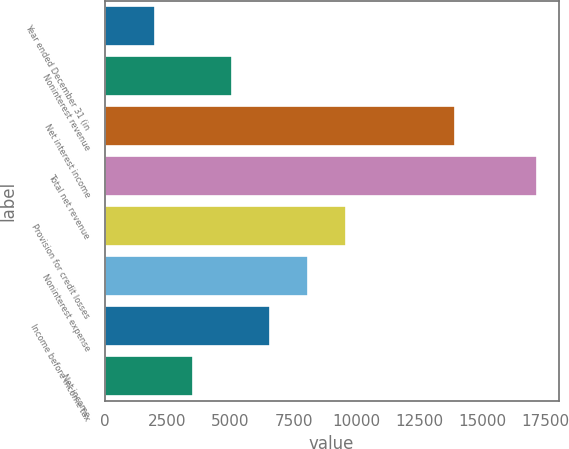<chart> <loc_0><loc_0><loc_500><loc_500><bar_chart><fcel>Year ended December 31 (in<fcel>Noninterest revenue<fcel>Net interest income<fcel>Total net revenue<fcel>Provision for credit losses<fcel>Noninterest expense<fcel>Income before income tax<fcel>Net income<nl><fcel>2010<fcel>5040.6<fcel>13886<fcel>17163<fcel>9586.5<fcel>8071.2<fcel>6555.9<fcel>3525.3<nl></chart> 